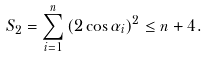<formula> <loc_0><loc_0><loc_500><loc_500>S _ { 2 } = \sum _ { i = 1 } ^ { n } \left ( 2 \cos \alpha _ { i } \right ) ^ { 2 } \leq n + 4 .</formula> 